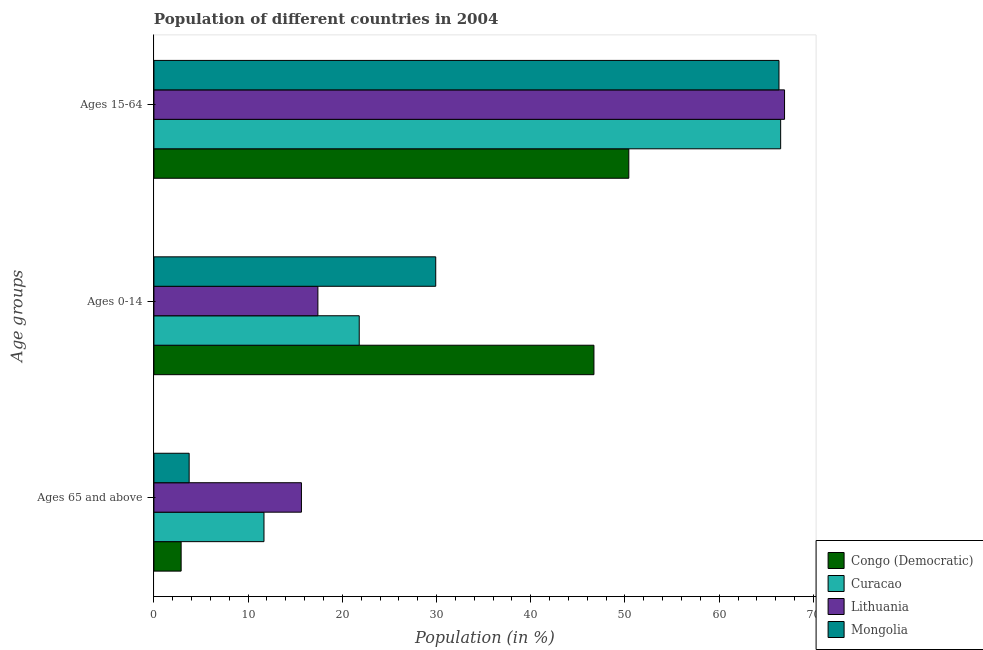How many different coloured bars are there?
Your response must be concise. 4. How many bars are there on the 1st tick from the top?
Your response must be concise. 4. How many bars are there on the 2nd tick from the bottom?
Keep it short and to the point. 4. What is the label of the 2nd group of bars from the top?
Offer a very short reply. Ages 0-14. What is the percentage of population within the age-group 0-14 in Curacao?
Your response must be concise. 21.79. Across all countries, what is the maximum percentage of population within the age-group 0-14?
Offer a terse response. 46.7. Across all countries, what is the minimum percentage of population within the age-group 0-14?
Your response must be concise. 17.4. In which country was the percentage of population within the age-group 0-14 maximum?
Provide a succinct answer. Congo (Democratic). In which country was the percentage of population within the age-group of 65 and above minimum?
Offer a terse response. Congo (Democratic). What is the total percentage of population within the age-group 15-64 in the graph?
Keep it short and to the point. 250.22. What is the difference between the percentage of population within the age-group of 65 and above in Curacao and that in Lithuania?
Offer a very short reply. -3.98. What is the difference between the percentage of population within the age-group 15-64 in Curacao and the percentage of population within the age-group 0-14 in Lithuania?
Provide a short and direct response. 49.12. What is the average percentage of population within the age-group 0-14 per country?
Your answer should be compact. 28.95. What is the difference between the percentage of population within the age-group of 65 and above and percentage of population within the age-group 15-64 in Congo (Democratic)?
Your answer should be compact. -47.52. In how many countries, is the percentage of population within the age-group of 65 and above greater than 22 %?
Your answer should be very brief. 0. What is the ratio of the percentage of population within the age-group 0-14 in Congo (Democratic) to that in Curacao?
Keep it short and to the point. 2.14. What is the difference between the highest and the second highest percentage of population within the age-group of 65 and above?
Your answer should be very brief. 3.98. What is the difference between the highest and the lowest percentage of population within the age-group 15-64?
Provide a short and direct response. 16.53. In how many countries, is the percentage of population within the age-group 0-14 greater than the average percentage of population within the age-group 0-14 taken over all countries?
Give a very brief answer. 2. What does the 2nd bar from the top in Ages 0-14 represents?
Keep it short and to the point. Lithuania. What does the 2nd bar from the bottom in Ages 0-14 represents?
Offer a terse response. Curacao. How many bars are there?
Provide a short and direct response. 12. What is the difference between two consecutive major ticks on the X-axis?
Give a very brief answer. 10. Are the values on the major ticks of X-axis written in scientific E-notation?
Provide a succinct answer. No. Does the graph contain grids?
Ensure brevity in your answer.  No. Where does the legend appear in the graph?
Offer a terse response. Bottom right. What is the title of the graph?
Provide a succinct answer. Population of different countries in 2004. Does "Morocco" appear as one of the legend labels in the graph?
Give a very brief answer. No. What is the label or title of the X-axis?
Ensure brevity in your answer.  Population (in %). What is the label or title of the Y-axis?
Make the answer very short. Age groups. What is the Population (in %) in Congo (Democratic) in Ages 65 and above?
Give a very brief answer. 2.89. What is the Population (in %) of Curacao in Ages 65 and above?
Your answer should be compact. 11.68. What is the Population (in %) of Lithuania in Ages 65 and above?
Provide a succinct answer. 15.66. What is the Population (in %) of Mongolia in Ages 65 and above?
Ensure brevity in your answer.  3.74. What is the Population (in %) in Congo (Democratic) in Ages 0-14?
Your answer should be very brief. 46.7. What is the Population (in %) in Curacao in Ages 0-14?
Ensure brevity in your answer.  21.79. What is the Population (in %) of Lithuania in Ages 0-14?
Your response must be concise. 17.4. What is the Population (in %) of Mongolia in Ages 0-14?
Offer a terse response. 29.91. What is the Population (in %) of Congo (Democratic) in Ages 15-64?
Provide a short and direct response. 50.41. What is the Population (in %) of Curacao in Ages 15-64?
Your response must be concise. 66.53. What is the Population (in %) in Lithuania in Ages 15-64?
Provide a succinct answer. 66.94. What is the Population (in %) of Mongolia in Ages 15-64?
Provide a succinct answer. 66.35. Across all Age groups, what is the maximum Population (in %) in Congo (Democratic)?
Offer a terse response. 50.41. Across all Age groups, what is the maximum Population (in %) of Curacao?
Provide a succinct answer. 66.53. Across all Age groups, what is the maximum Population (in %) of Lithuania?
Keep it short and to the point. 66.94. Across all Age groups, what is the maximum Population (in %) in Mongolia?
Your answer should be compact. 66.35. Across all Age groups, what is the minimum Population (in %) of Congo (Democratic)?
Your answer should be compact. 2.89. Across all Age groups, what is the minimum Population (in %) of Curacao?
Make the answer very short. 11.68. Across all Age groups, what is the minimum Population (in %) in Lithuania?
Offer a terse response. 15.66. Across all Age groups, what is the minimum Population (in %) of Mongolia?
Give a very brief answer. 3.74. What is the total Population (in %) in Congo (Democratic) in the graph?
Give a very brief answer. 100. What is the total Population (in %) of Lithuania in the graph?
Make the answer very short. 100. What is the difference between the Population (in %) in Congo (Democratic) in Ages 65 and above and that in Ages 0-14?
Keep it short and to the point. -43.82. What is the difference between the Population (in %) in Curacao in Ages 65 and above and that in Ages 0-14?
Your answer should be very brief. -10.11. What is the difference between the Population (in %) of Lithuania in Ages 65 and above and that in Ages 0-14?
Your answer should be very brief. -1.75. What is the difference between the Population (in %) of Mongolia in Ages 65 and above and that in Ages 0-14?
Offer a terse response. -26.17. What is the difference between the Population (in %) of Congo (Democratic) in Ages 65 and above and that in Ages 15-64?
Ensure brevity in your answer.  -47.52. What is the difference between the Population (in %) in Curacao in Ages 65 and above and that in Ages 15-64?
Make the answer very short. -54.84. What is the difference between the Population (in %) of Lithuania in Ages 65 and above and that in Ages 15-64?
Your response must be concise. -51.28. What is the difference between the Population (in %) in Mongolia in Ages 65 and above and that in Ages 15-64?
Ensure brevity in your answer.  -62.61. What is the difference between the Population (in %) in Congo (Democratic) in Ages 0-14 and that in Ages 15-64?
Give a very brief answer. -3.7. What is the difference between the Population (in %) of Curacao in Ages 0-14 and that in Ages 15-64?
Offer a terse response. -44.73. What is the difference between the Population (in %) of Lithuania in Ages 0-14 and that in Ages 15-64?
Provide a succinct answer. -49.54. What is the difference between the Population (in %) in Mongolia in Ages 0-14 and that in Ages 15-64?
Your answer should be very brief. -36.43. What is the difference between the Population (in %) of Congo (Democratic) in Ages 65 and above and the Population (in %) of Curacao in Ages 0-14?
Provide a short and direct response. -18.9. What is the difference between the Population (in %) in Congo (Democratic) in Ages 65 and above and the Population (in %) in Lithuania in Ages 0-14?
Offer a terse response. -14.51. What is the difference between the Population (in %) in Congo (Democratic) in Ages 65 and above and the Population (in %) in Mongolia in Ages 0-14?
Ensure brevity in your answer.  -27.02. What is the difference between the Population (in %) of Curacao in Ages 65 and above and the Population (in %) of Lithuania in Ages 0-14?
Offer a terse response. -5.72. What is the difference between the Population (in %) of Curacao in Ages 65 and above and the Population (in %) of Mongolia in Ages 0-14?
Keep it short and to the point. -18.23. What is the difference between the Population (in %) of Lithuania in Ages 65 and above and the Population (in %) of Mongolia in Ages 0-14?
Provide a succinct answer. -14.26. What is the difference between the Population (in %) of Congo (Democratic) in Ages 65 and above and the Population (in %) of Curacao in Ages 15-64?
Ensure brevity in your answer.  -63.64. What is the difference between the Population (in %) of Congo (Democratic) in Ages 65 and above and the Population (in %) of Lithuania in Ages 15-64?
Provide a short and direct response. -64.05. What is the difference between the Population (in %) in Congo (Democratic) in Ages 65 and above and the Population (in %) in Mongolia in Ages 15-64?
Make the answer very short. -63.46. What is the difference between the Population (in %) of Curacao in Ages 65 and above and the Population (in %) of Lithuania in Ages 15-64?
Keep it short and to the point. -55.26. What is the difference between the Population (in %) of Curacao in Ages 65 and above and the Population (in %) of Mongolia in Ages 15-64?
Keep it short and to the point. -54.66. What is the difference between the Population (in %) of Lithuania in Ages 65 and above and the Population (in %) of Mongolia in Ages 15-64?
Ensure brevity in your answer.  -50.69. What is the difference between the Population (in %) of Congo (Democratic) in Ages 0-14 and the Population (in %) of Curacao in Ages 15-64?
Your answer should be very brief. -19.82. What is the difference between the Population (in %) of Congo (Democratic) in Ages 0-14 and the Population (in %) of Lithuania in Ages 15-64?
Ensure brevity in your answer.  -20.23. What is the difference between the Population (in %) in Congo (Democratic) in Ages 0-14 and the Population (in %) in Mongolia in Ages 15-64?
Your answer should be very brief. -19.64. What is the difference between the Population (in %) of Curacao in Ages 0-14 and the Population (in %) of Lithuania in Ages 15-64?
Provide a succinct answer. -45.15. What is the difference between the Population (in %) in Curacao in Ages 0-14 and the Population (in %) in Mongolia in Ages 15-64?
Your response must be concise. -44.56. What is the difference between the Population (in %) of Lithuania in Ages 0-14 and the Population (in %) of Mongolia in Ages 15-64?
Ensure brevity in your answer.  -48.94. What is the average Population (in %) in Congo (Democratic) per Age groups?
Your answer should be very brief. 33.33. What is the average Population (in %) of Curacao per Age groups?
Your answer should be compact. 33.33. What is the average Population (in %) of Lithuania per Age groups?
Offer a terse response. 33.33. What is the average Population (in %) in Mongolia per Age groups?
Your answer should be compact. 33.33. What is the difference between the Population (in %) of Congo (Democratic) and Population (in %) of Curacao in Ages 65 and above?
Provide a short and direct response. -8.79. What is the difference between the Population (in %) in Congo (Democratic) and Population (in %) in Lithuania in Ages 65 and above?
Keep it short and to the point. -12.77. What is the difference between the Population (in %) in Congo (Democratic) and Population (in %) in Mongolia in Ages 65 and above?
Provide a succinct answer. -0.85. What is the difference between the Population (in %) in Curacao and Population (in %) in Lithuania in Ages 65 and above?
Keep it short and to the point. -3.98. What is the difference between the Population (in %) in Curacao and Population (in %) in Mongolia in Ages 65 and above?
Your answer should be very brief. 7.94. What is the difference between the Population (in %) in Lithuania and Population (in %) in Mongolia in Ages 65 and above?
Provide a short and direct response. 11.92. What is the difference between the Population (in %) of Congo (Democratic) and Population (in %) of Curacao in Ages 0-14?
Provide a succinct answer. 24.91. What is the difference between the Population (in %) in Congo (Democratic) and Population (in %) in Lithuania in Ages 0-14?
Provide a short and direct response. 29.3. What is the difference between the Population (in %) in Congo (Democratic) and Population (in %) in Mongolia in Ages 0-14?
Your answer should be very brief. 16.79. What is the difference between the Population (in %) in Curacao and Population (in %) in Lithuania in Ages 0-14?
Offer a terse response. 4.39. What is the difference between the Population (in %) in Curacao and Population (in %) in Mongolia in Ages 0-14?
Keep it short and to the point. -8.12. What is the difference between the Population (in %) of Lithuania and Population (in %) of Mongolia in Ages 0-14?
Your response must be concise. -12.51. What is the difference between the Population (in %) of Congo (Democratic) and Population (in %) of Curacao in Ages 15-64?
Keep it short and to the point. -16.12. What is the difference between the Population (in %) in Congo (Democratic) and Population (in %) in Lithuania in Ages 15-64?
Give a very brief answer. -16.53. What is the difference between the Population (in %) in Congo (Democratic) and Population (in %) in Mongolia in Ages 15-64?
Keep it short and to the point. -15.94. What is the difference between the Population (in %) in Curacao and Population (in %) in Lithuania in Ages 15-64?
Make the answer very short. -0.41. What is the difference between the Population (in %) of Curacao and Population (in %) of Mongolia in Ages 15-64?
Offer a very short reply. 0.18. What is the difference between the Population (in %) of Lithuania and Population (in %) of Mongolia in Ages 15-64?
Your response must be concise. 0.59. What is the ratio of the Population (in %) of Congo (Democratic) in Ages 65 and above to that in Ages 0-14?
Offer a terse response. 0.06. What is the ratio of the Population (in %) in Curacao in Ages 65 and above to that in Ages 0-14?
Provide a succinct answer. 0.54. What is the ratio of the Population (in %) of Lithuania in Ages 65 and above to that in Ages 0-14?
Keep it short and to the point. 0.9. What is the ratio of the Population (in %) in Congo (Democratic) in Ages 65 and above to that in Ages 15-64?
Your answer should be very brief. 0.06. What is the ratio of the Population (in %) in Curacao in Ages 65 and above to that in Ages 15-64?
Your response must be concise. 0.18. What is the ratio of the Population (in %) in Lithuania in Ages 65 and above to that in Ages 15-64?
Offer a terse response. 0.23. What is the ratio of the Population (in %) of Mongolia in Ages 65 and above to that in Ages 15-64?
Offer a terse response. 0.06. What is the ratio of the Population (in %) of Congo (Democratic) in Ages 0-14 to that in Ages 15-64?
Offer a very short reply. 0.93. What is the ratio of the Population (in %) of Curacao in Ages 0-14 to that in Ages 15-64?
Your response must be concise. 0.33. What is the ratio of the Population (in %) in Lithuania in Ages 0-14 to that in Ages 15-64?
Your response must be concise. 0.26. What is the ratio of the Population (in %) in Mongolia in Ages 0-14 to that in Ages 15-64?
Give a very brief answer. 0.45. What is the difference between the highest and the second highest Population (in %) in Congo (Democratic)?
Offer a terse response. 3.7. What is the difference between the highest and the second highest Population (in %) of Curacao?
Ensure brevity in your answer.  44.73. What is the difference between the highest and the second highest Population (in %) of Lithuania?
Provide a succinct answer. 49.54. What is the difference between the highest and the second highest Population (in %) of Mongolia?
Offer a very short reply. 36.43. What is the difference between the highest and the lowest Population (in %) of Congo (Democratic)?
Provide a succinct answer. 47.52. What is the difference between the highest and the lowest Population (in %) in Curacao?
Your response must be concise. 54.84. What is the difference between the highest and the lowest Population (in %) of Lithuania?
Your answer should be compact. 51.28. What is the difference between the highest and the lowest Population (in %) in Mongolia?
Make the answer very short. 62.61. 